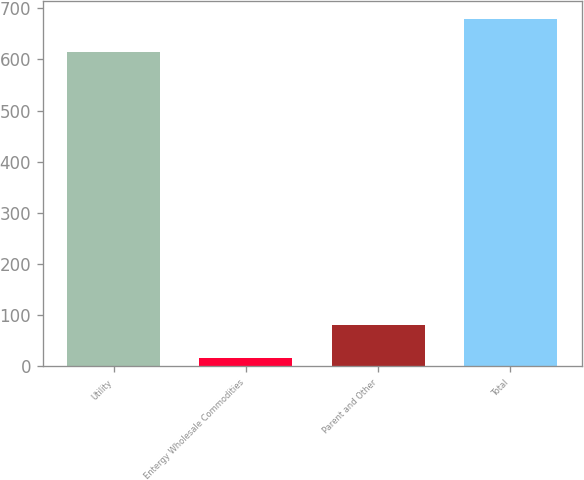Convert chart. <chart><loc_0><loc_0><loc_500><loc_500><bar_chart><fcel>Utility<fcel>Entergy Wholesale Commodities<fcel>Parent and Other<fcel>Total<nl><fcel>614<fcel>16<fcel>81.7<fcel>679.7<nl></chart> 